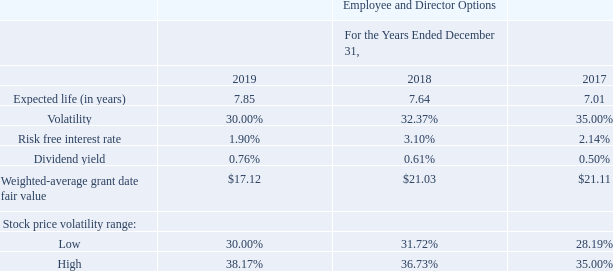Fair Value Valuation Assumptions
Valuation of Stock Options
The fair value of stock options granted are principally estimated using a binomial-lattice model. The inputs in our binomial-lattice model include expected stock price volatility, risk-free interest rate, dividend yield, contractual term, and vesting schedule, as well as measures of employees’ cancellations, exercise, and post-vesting termination behavior. Statistical methods are used to estimate employee termination rates.
The following table presents the weighted-average assumptions, weighted average grant date fair value, and the range of expected stock price volatilities:
Expected life The expected life of employee stock options is a derived output of the binomial-lattice model and represents the weighted-average period the stock options are expected to remain outstanding. A binomial-lattice model assumes that employees will exercise their options when the stock price equals or exceeds an exercise multiple. The exercise multiple is based on historical employee exercise behaviors.
Volatility To estimate volatility for the binomial-lattice model, we consider the implied volatility of exchange-traded options on our stock to estimate short-term volatility, the historical volatility of our common shares during the option’s contractual term to estimate long-term volatility, and a statistical model to estimate the transition from short-term volatility to long-term volatility.
Risk-free interest rate As is the case for volatility, the risk-free interest rate is assumed to change during the option’s contractual term. The riskfree interest rate, which is based on U.S. Treasury yield curves, reflects the expected movement in the interest rate from one time period to the next (“forward rate”).
Dividend yield The expected dividend yield assumption is based on our historical and expected future amount of dividend payouts. Share-based compensation expense recognized is based on awards ultimately expected to vest and therefore has been reduced for estimated forfeitures. Forfeitures are estimated at the time of grant based on historical experience and revised, if necessary, in subsequent periods if actual forfeitures differ from those estimates.
How was the fair value of stock options granted estimated by? Using a binomial-lattice model. What was the expected life (in years) for 2019? 7.85. What was the volatility in 2018? 32.37%. What was the change in volatility between 2018 and 2019?
Answer scale should be: percent. 30.00%-32.37%
Answer: -2.37. What was the change in risk free interest rate between 2017 and 2018?
Answer scale should be: percent. 3.10%-2.14%
Answer: 0.96. What was the percentage change in the weighted-average grant date fair value between 2018 and 2019?
Answer scale should be: percent. ($17.12-$21.03)/$21.03
Answer: -18.59. 